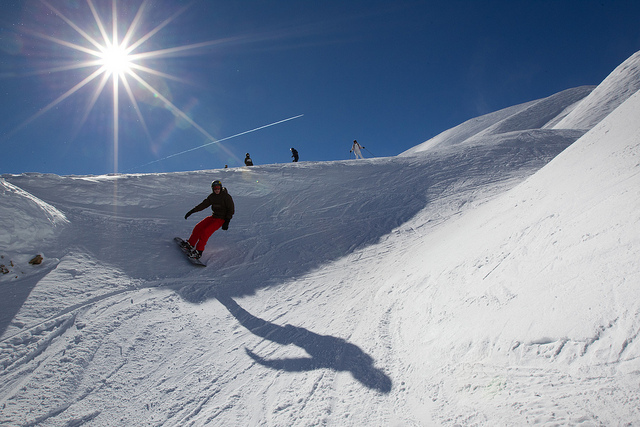Does this image look like it's taken during a competition or a leisure activity? The image appears to capture a leisure activity rather than a competition. The snowboarder seems to be riding freely down the slope without any visible race markers or spectators that are commonly associated with snowboarding competitions. 